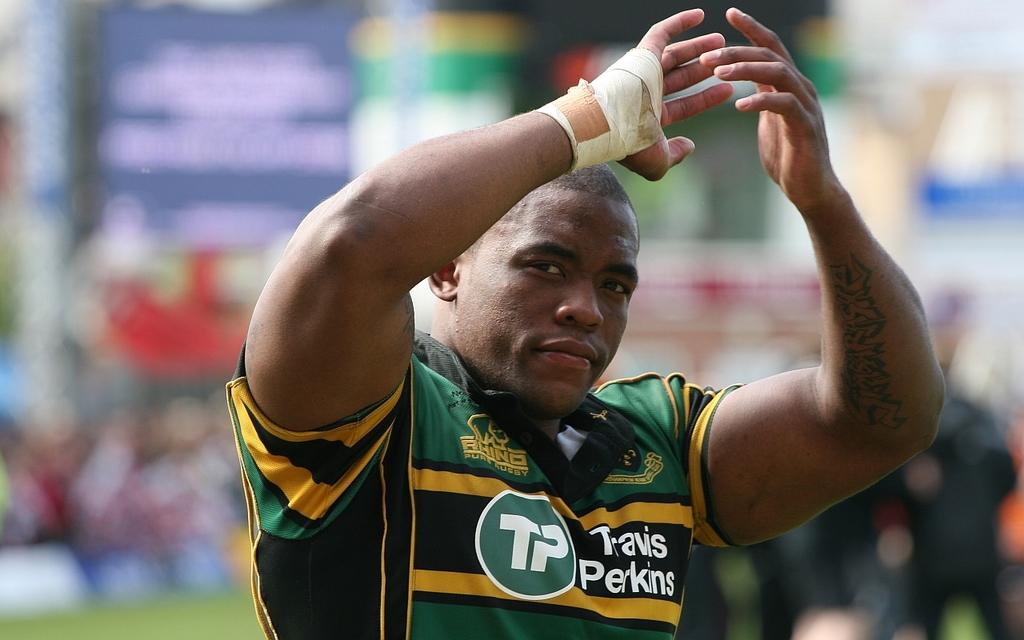What is written on his shirt ?
Make the answer very short. Travis perkins. 